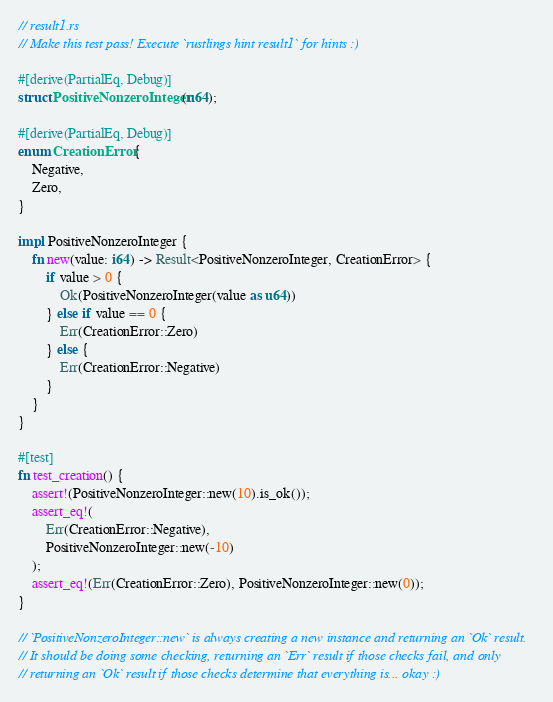<code> <loc_0><loc_0><loc_500><loc_500><_Rust_>// result1.rs
// Make this test pass! Execute `rustlings hint result1` for hints :)

#[derive(PartialEq, Debug)]
struct PositiveNonzeroInteger(u64);

#[derive(PartialEq, Debug)]
enum CreationError {
    Negative,
    Zero,
}

impl PositiveNonzeroInteger {
    fn new(value: i64) -> Result<PositiveNonzeroInteger, CreationError> {
        if value > 0 {
            Ok(PositiveNonzeroInteger(value as u64))
        } else if value == 0 {
            Err(CreationError::Zero)
        } else {
            Err(CreationError::Negative)
        }
    }
}

#[test]
fn test_creation() {
    assert!(PositiveNonzeroInteger::new(10).is_ok());
    assert_eq!(
        Err(CreationError::Negative),
        PositiveNonzeroInteger::new(-10)
    );
    assert_eq!(Err(CreationError::Zero), PositiveNonzeroInteger::new(0));
}

// `PositiveNonzeroInteger::new` is always creating a new instance and returning an `Ok` result.
// It should be doing some checking, returning an `Err` result if those checks fail, and only
// returning an `Ok` result if those checks determine that everything is... okay :)
</code> 